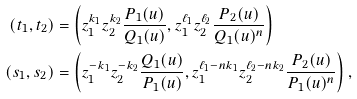Convert formula to latex. <formula><loc_0><loc_0><loc_500><loc_500>\left ( t _ { 1 } , t _ { 2 } \right ) & = \left ( z _ { 1 } ^ { k _ { 1 } } z _ { 2 } ^ { k _ { 2 } } \frac { P _ { 1 } ( u ) } { Q _ { 1 } ( u ) } , z _ { 1 } ^ { \ell _ { 1 } } z _ { 2 } ^ { \ell _ { 2 } } \frac { P _ { 2 } ( u ) } { Q _ { 1 } ( u ) ^ { n } } \right ) \\ \left ( s _ { 1 } , s _ { 2 } \right ) & = \left ( z _ { 1 } ^ { - k _ { 1 } } z _ { 2 } ^ { - k _ { 2 } } \frac { Q _ { 1 } ( u ) } { P _ { 1 } ( u ) } , z _ { 1 } ^ { \ell _ { 1 } - n k _ { 1 } } z _ { 2 } ^ { \ell _ { 2 } - n k _ { 2 } } \frac { P _ { 2 } ( u ) } { P _ { 1 } ( u ) ^ { n } } \right ) ,</formula> 